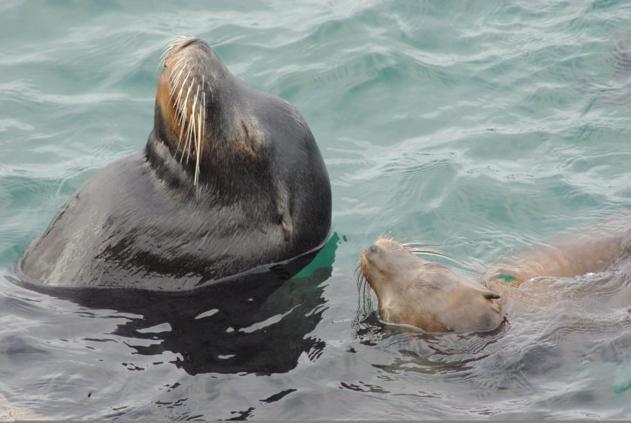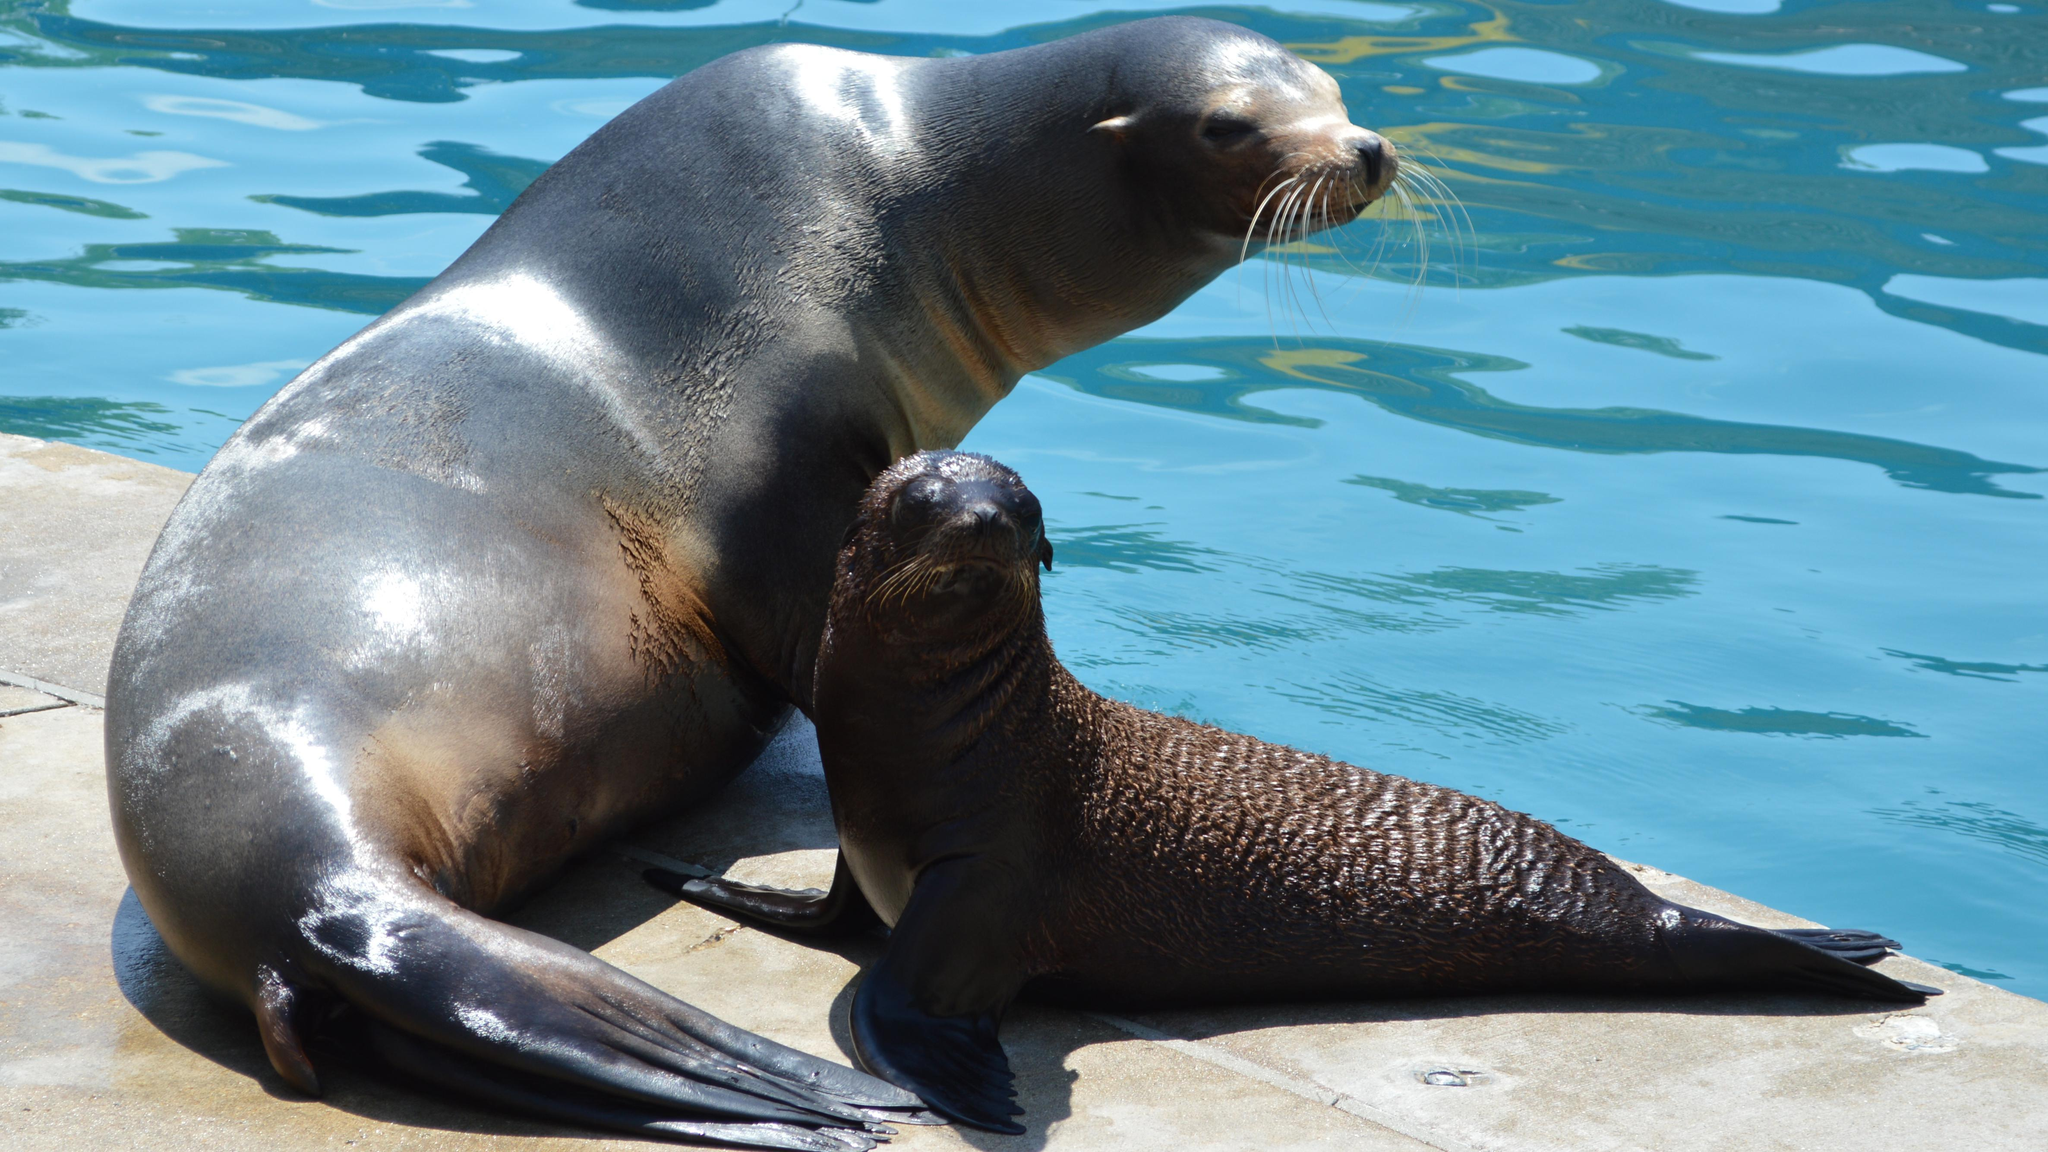The first image is the image on the left, the second image is the image on the right. Given the left and right images, does the statement "One image includes a close-mouthed seal with its face poking up out of the water, and the other image includes multiple seals at the edge of water." hold true? Answer yes or no. Yes. The first image is the image on the left, the second image is the image on the right. Assess this claim about the two images: "The seals in the image on the right are sunning on a rock.". Correct or not? Answer yes or no. Yes. 